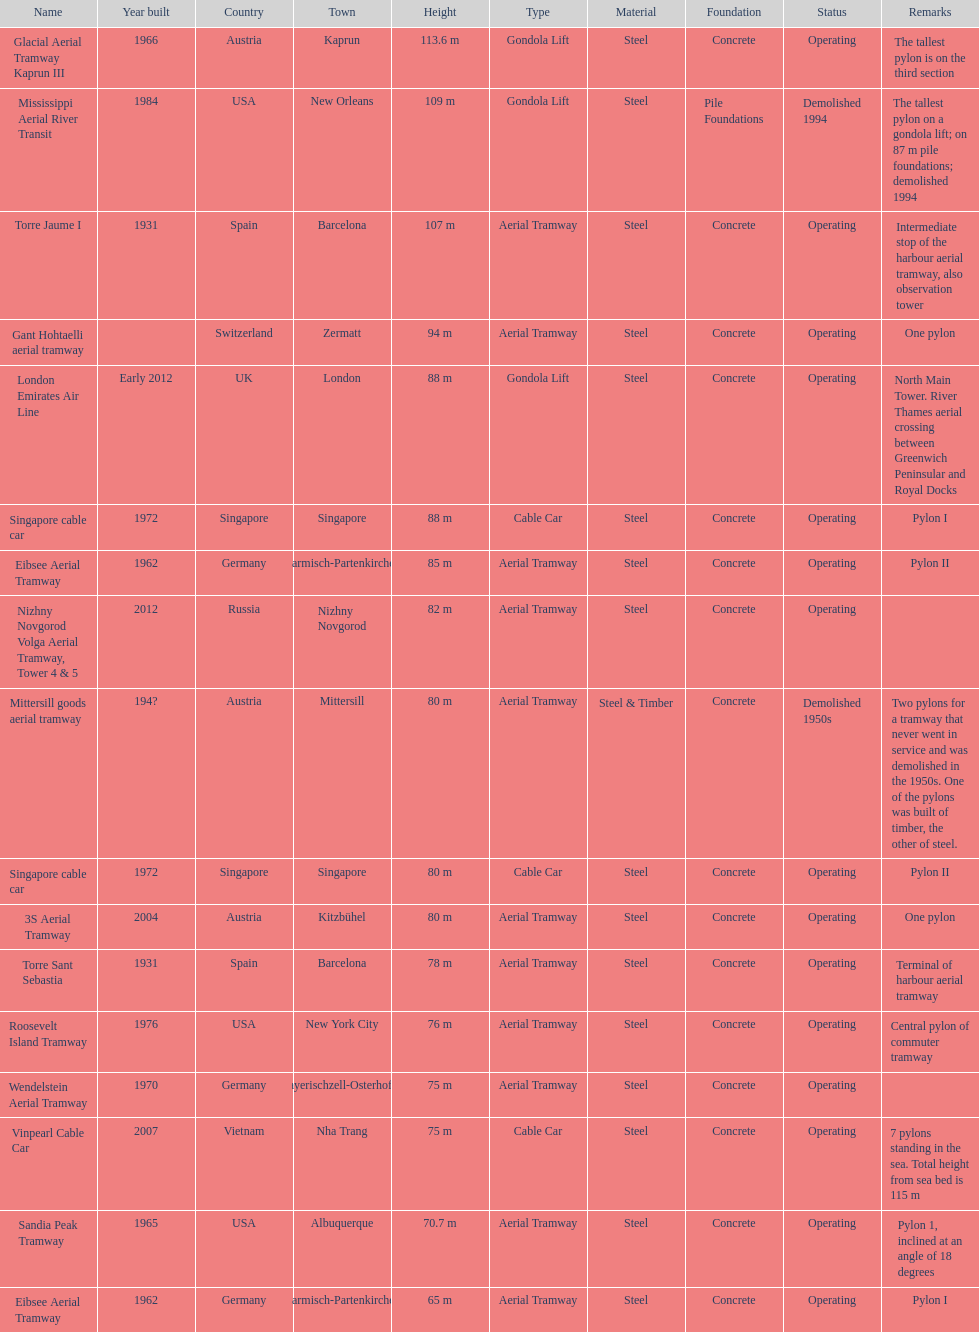How many metres is the mississippi aerial river transit from bottom to top? 109 m. 